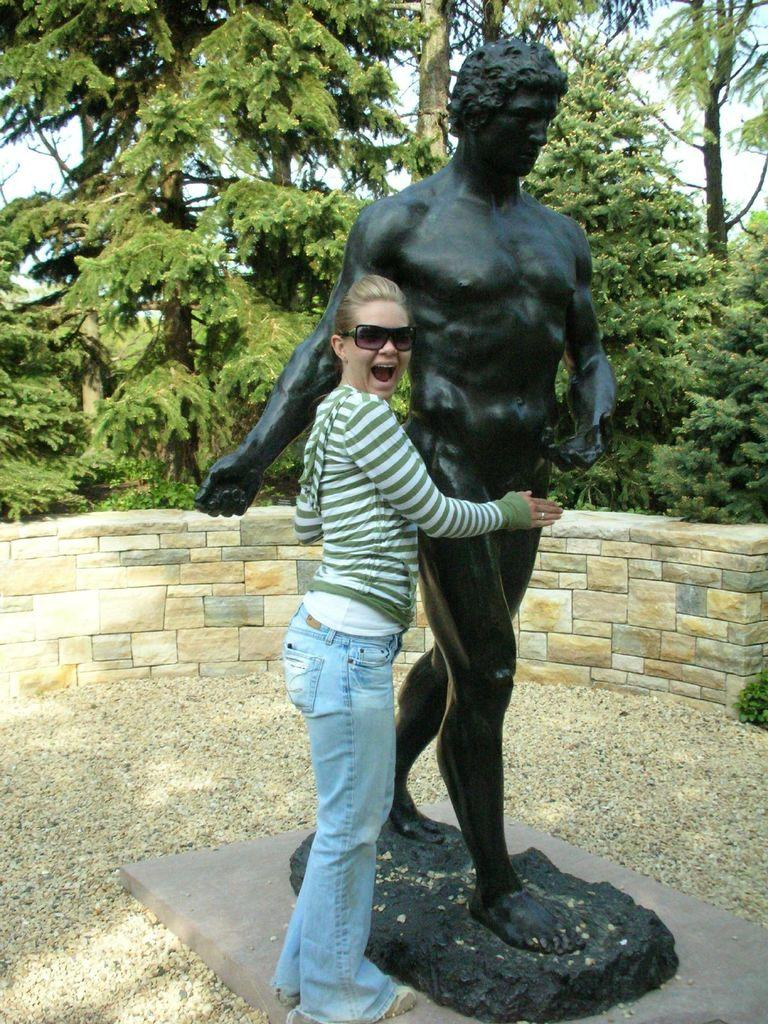What is the main subject in the image? There is a person standing in the image. What can be seen beside the person? There is a black colored statue beside the person. What is visible in the background of the image? There is a rock wall, green trees, and the sky visible in the background of the image. What type of pencil is the person holding in the image? There is no pencil present in the image; the person is not holding anything. 